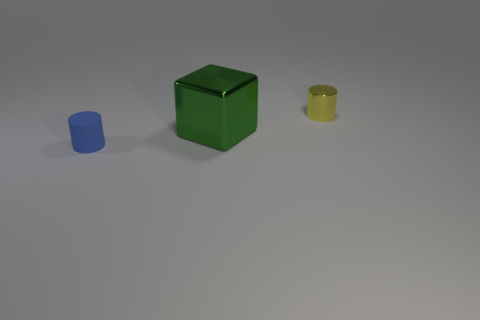Add 3 purple metal cylinders. How many objects exist? 6 Add 3 small purple shiny balls. How many small purple shiny balls exist? 3 Subtract 0 red blocks. How many objects are left? 3 Subtract all cubes. How many objects are left? 2 Subtract 1 cylinders. How many cylinders are left? 1 Subtract all green cylinders. Subtract all cyan cubes. How many cylinders are left? 2 Subtract all large red metal cylinders. Subtract all yellow metal things. How many objects are left? 2 Add 1 small yellow shiny cylinders. How many small yellow shiny cylinders are left? 2 